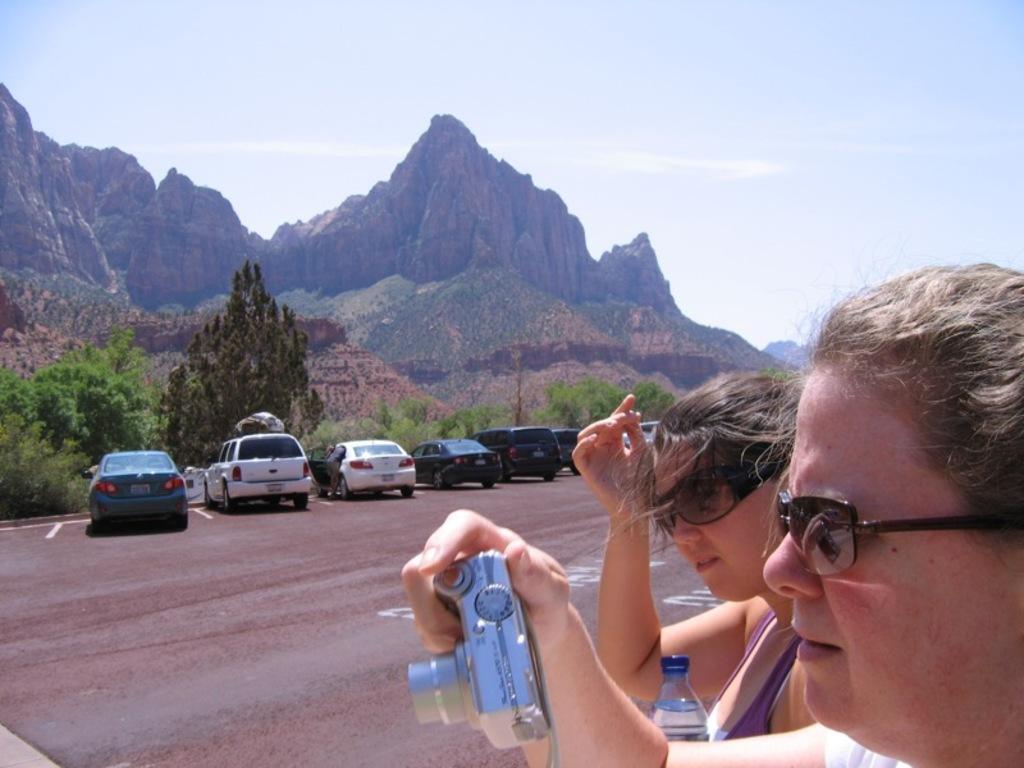Can you describe this image briefly? In this image I can see a person wearing black goggles is holding a camera in her hand and another person wearing black colored spectacles and holding a water bottle in her hand. In the background I can see few cars on the road, few trees, few mountains and the sky. 